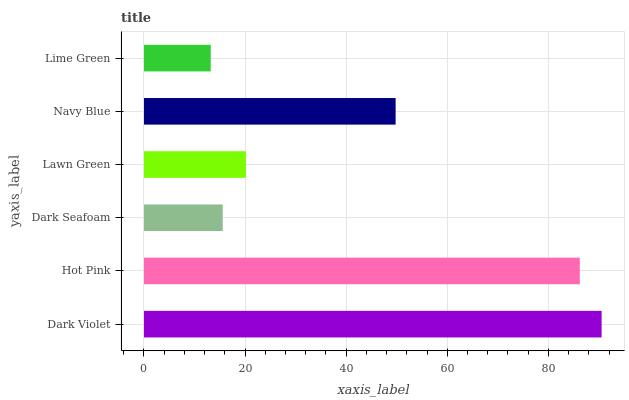Is Lime Green the minimum?
Answer yes or no. Yes. Is Dark Violet the maximum?
Answer yes or no. Yes. Is Hot Pink the minimum?
Answer yes or no. No. Is Hot Pink the maximum?
Answer yes or no. No. Is Dark Violet greater than Hot Pink?
Answer yes or no. Yes. Is Hot Pink less than Dark Violet?
Answer yes or no. Yes. Is Hot Pink greater than Dark Violet?
Answer yes or no. No. Is Dark Violet less than Hot Pink?
Answer yes or no. No. Is Navy Blue the high median?
Answer yes or no. Yes. Is Lawn Green the low median?
Answer yes or no. Yes. Is Dark Seafoam the high median?
Answer yes or no. No. Is Dark Violet the low median?
Answer yes or no. No. 